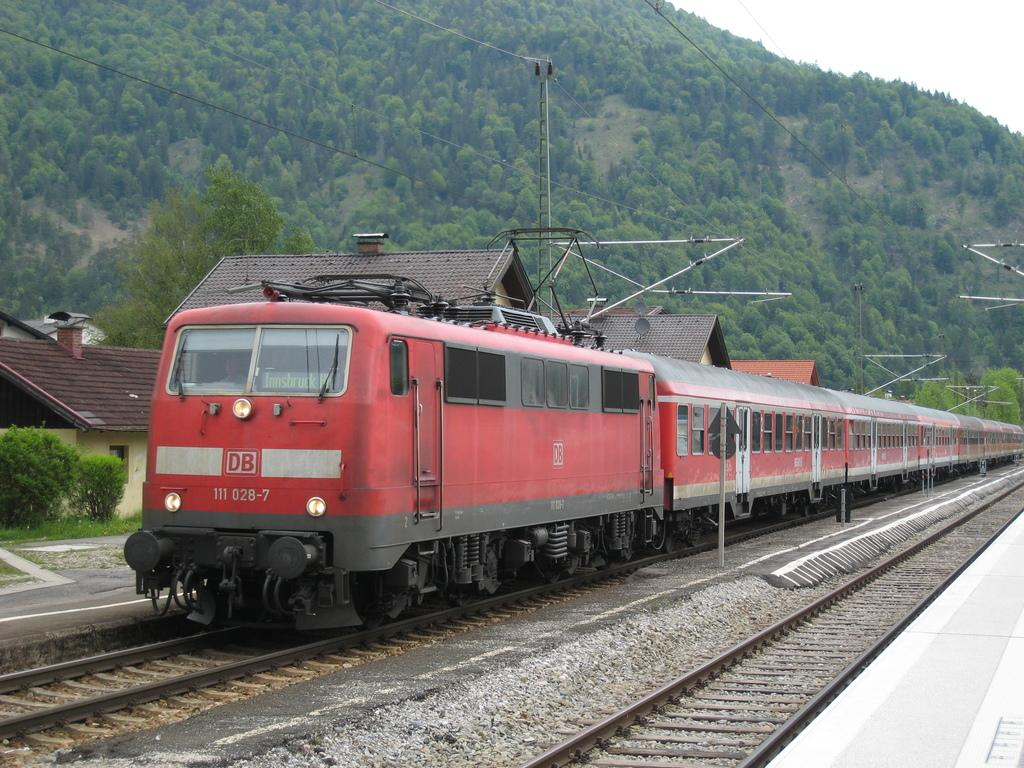<image>
Write a terse but informative summary of the picture. A red train with 111 028-7 on the front of it. 